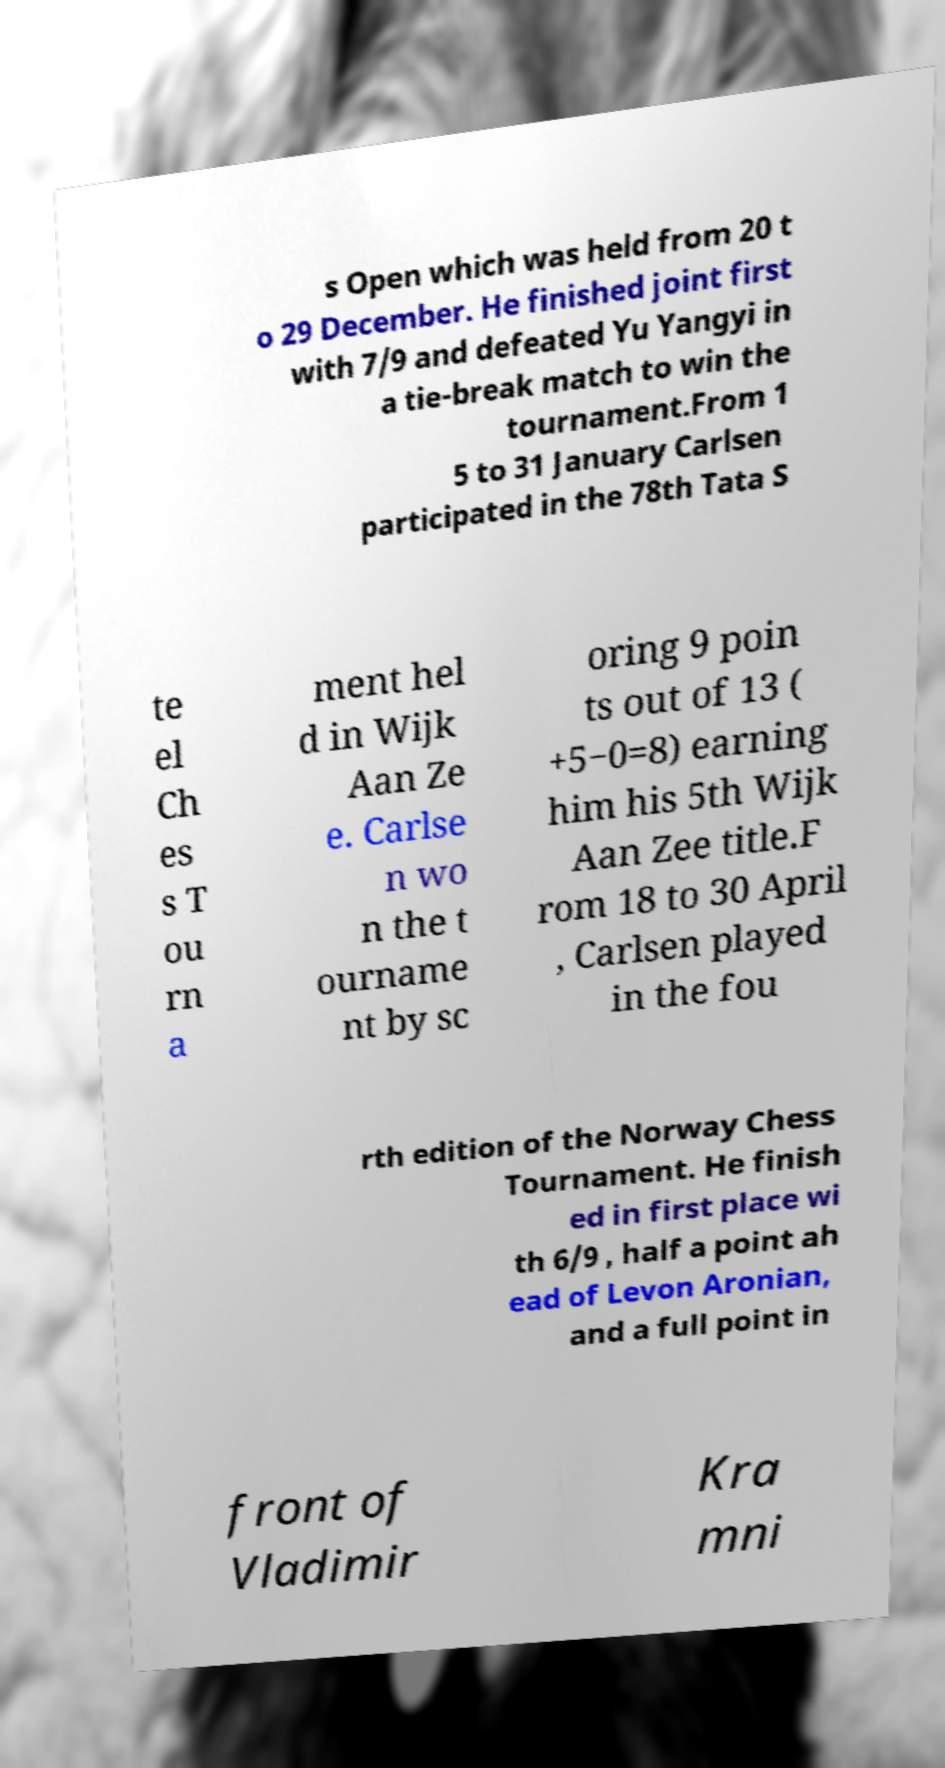Please identify and transcribe the text found in this image. s Open which was held from 20 t o 29 December. He finished joint first with 7/9 and defeated Yu Yangyi in a tie-break match to win the tournament.From 1 5 to 31 January Carlsen participated in the 78th Tata S te el Ch es s T ou rn a ment hel d in Wijk Aan Ze e. Carlse n wo n the t ourname nt by sc oring 9 poin ts out of 13 ( +5−0=8) earning him his 5th Wijk Aan Zee title.F rom 18 to 30 April , Carlsen played in the fou rth edition of the Norway Chess Tournament. He finish ed in first place wi th 6/9 , half a point ah ead of Levon Aronian, and a full point in front of Vladimir Kra mni 